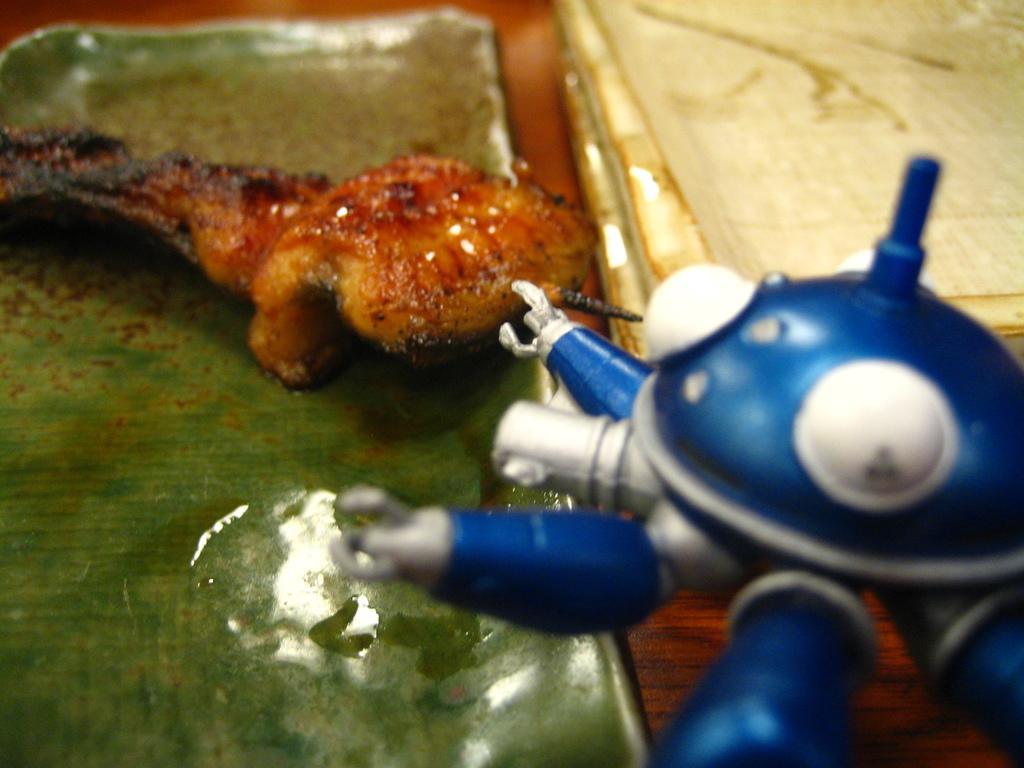Describe this image in one or two sentences. In this picture we can see some food in a leaf. There is a toy and white objects on the right side. 